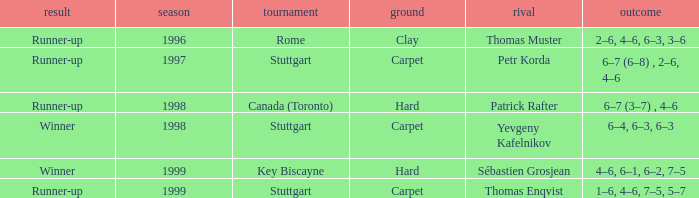How many years was the opponent petr korda? 1.0. 